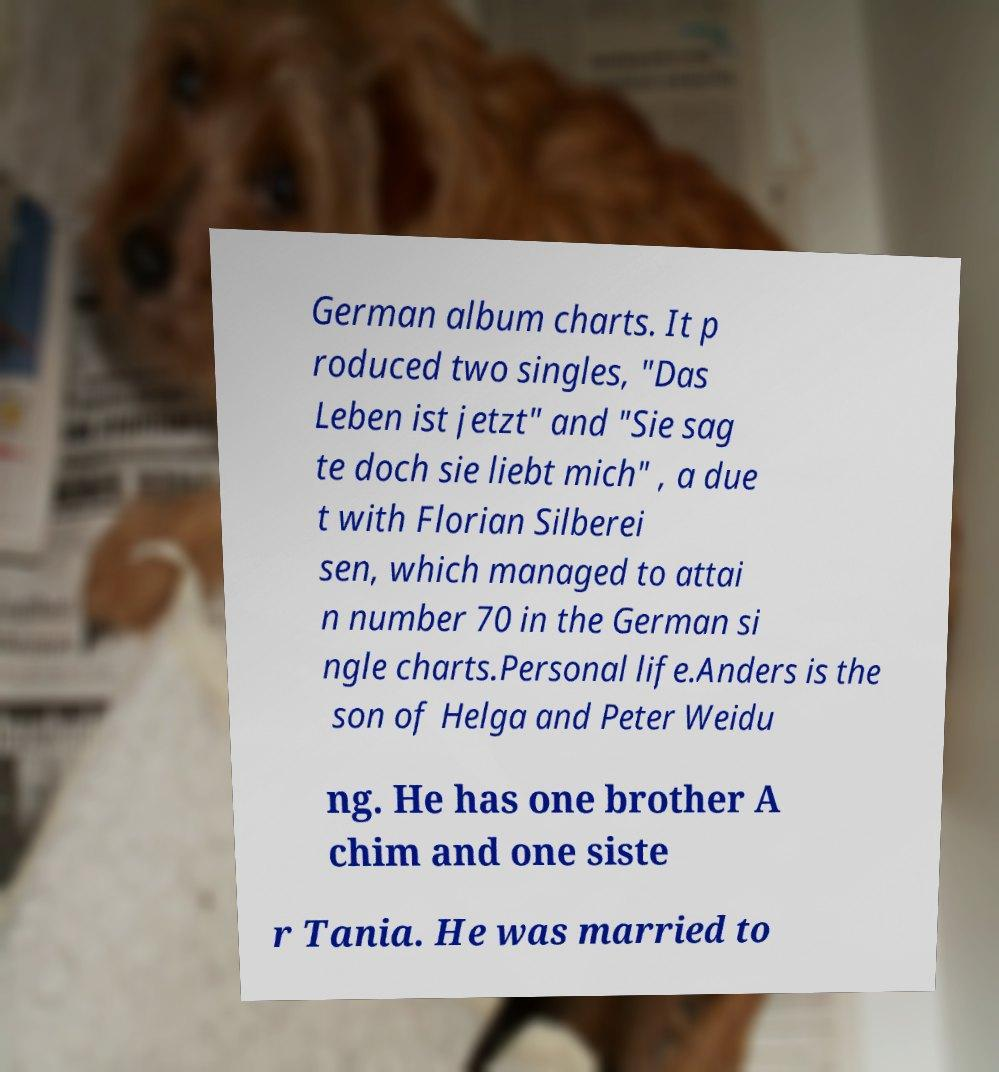Could you assist in decoding the text presented in this image and type it out clearly? German album charts. It p roduced two singles, "Das Leben ist jetzt" and "Sie sag te doch sie liebt mich" , a due t with Florian Silberei sen, which managed to attai n number 70 in the German si ngle charts.Personal life.Anders is the son of Helga and Peter Weidu ng. He has one brother A chim and one siste r Tania. He was married to 